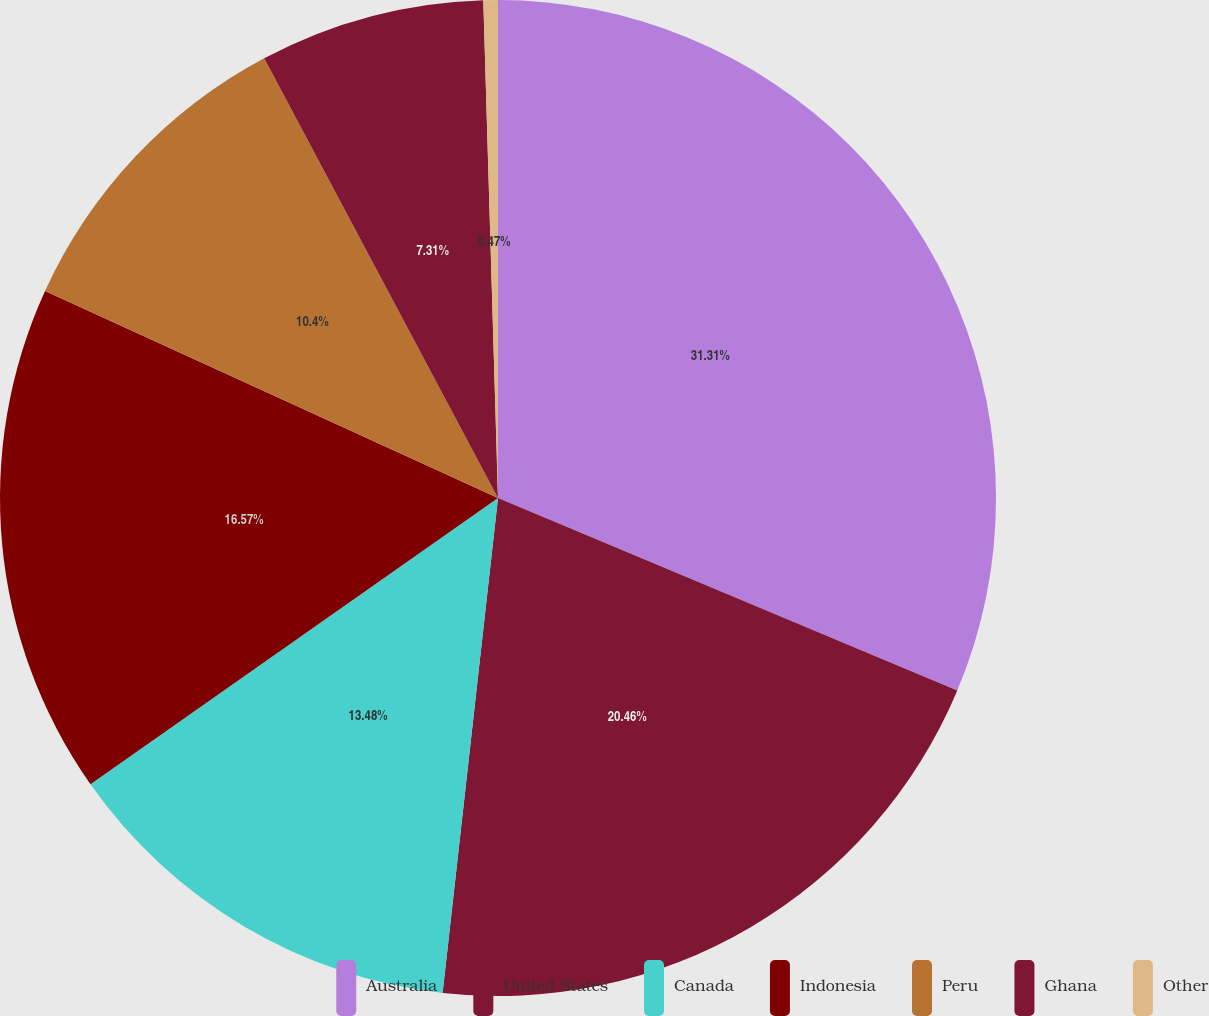<chart> <loc_0><loc_0><loc_500><loc_500><pie_chart><fcel>Australia<fcel>United States<fcel>Canada<fcel>Indonesia<fcel>Peru<fcel>Ghana<fcel>Other<nl><fcel>31.32%<fcel>20.46%<fcel>13.48%<fcel>16.57%<fcel>10.4%<fcel>7.31%<fcel>0.47%<nl></chart> 